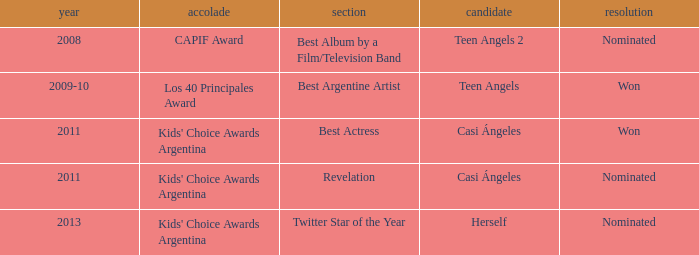For what award was there a nomination for Best Actress? Kids' Choice Awards Argentina. 